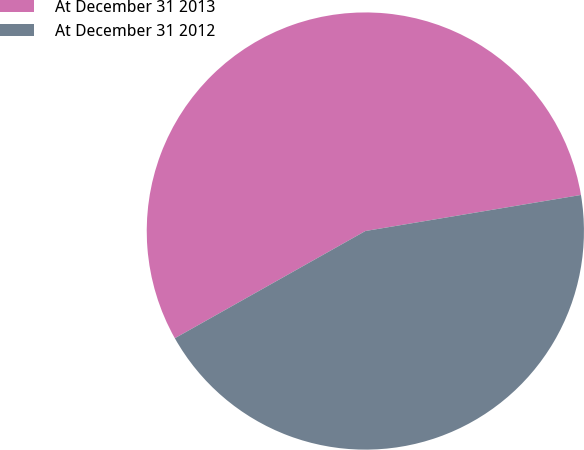Convert chart to OTSL. <chart><loc_0><loc_0><loc_500><loc_500><pie_chart><fcel>At December 31 2013<fcel>At December 31 2012<nl><fcel>55.52%<fcel>44.48%<nl></chart> 